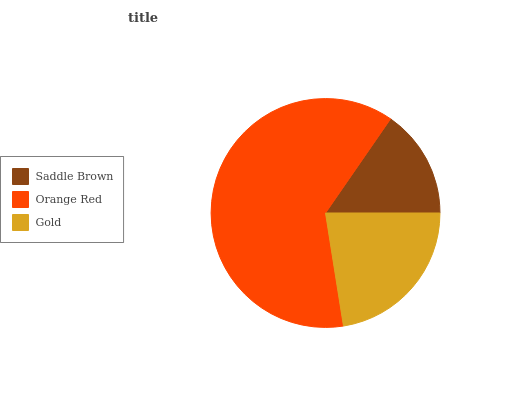Is Saddle Brown the minimum?
Answer yes or no. Yes. Is Orange Red the maximum?
Answer yes or no. Yes. Is Gold the minimum?
Answer yes or no. No. Is Gold the maximum?
Answer yes or no. No. Is Orange Red greater than Gold?
Answer yes or no. Yes. Is Gold less than Orange Red?
Answer yes or no. Yes. Is Gold greater than Orange Red?
Answer yes or no. No. Is Orange Red less than Gold?
Answer yes or no. No. Is Gold the high median?
Answer yes or no. Yes. Is Gold the low median?
Answer yes or no. Yes. Is Orange Red the high median?
Answer yes or no. No. Is Saddle Brown the low median?
Answer yes or no. No. 